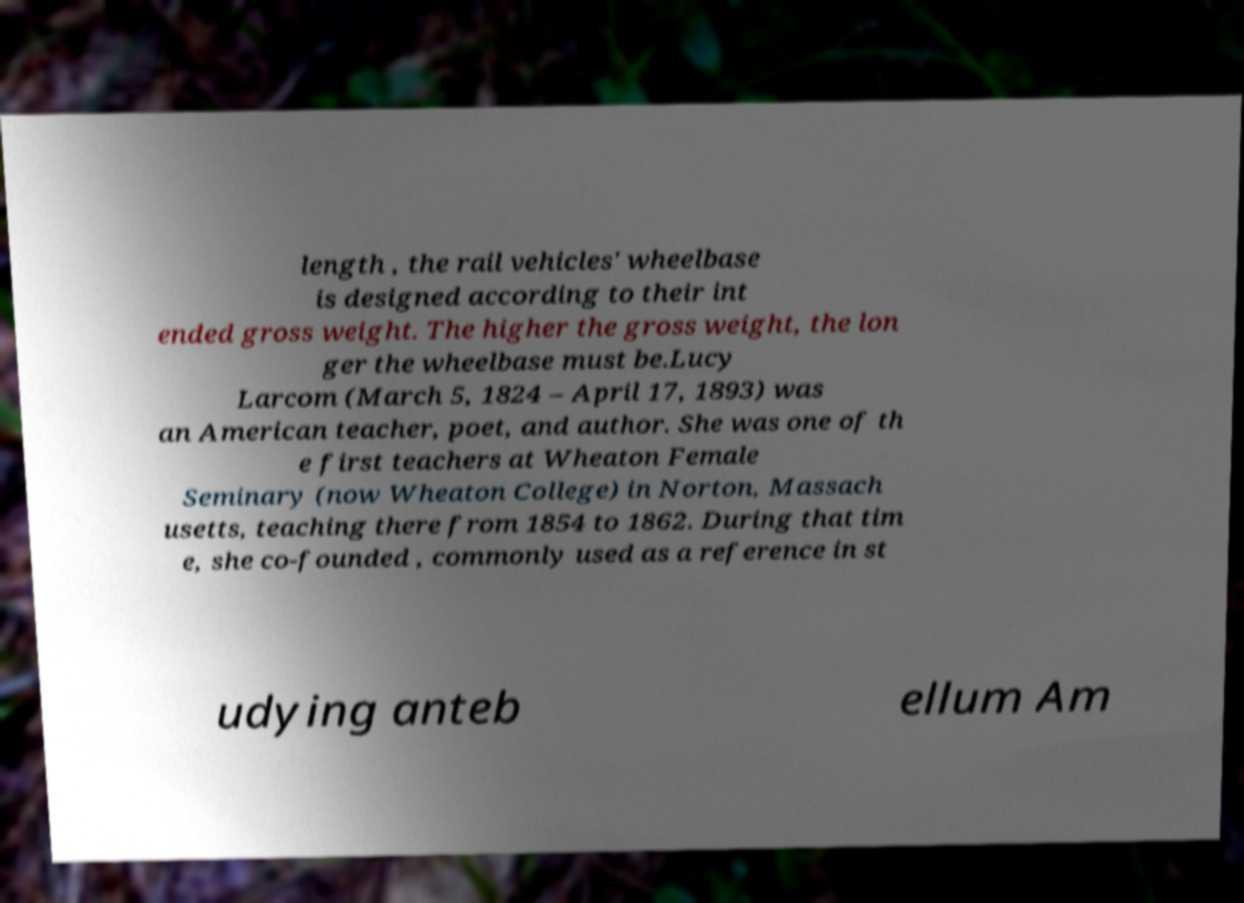I need the written content from this picture converted into text. Can you do that? length , the rail vehicles' wheelbase is designed according to their int ended gross weight. The higher the gross weight, the lon ger the wheelbase must be.Lucy Larcom (March 5, 1824 – April 17, 1893) was an American teacher, poet, and author. She was one of th e first teachers at Wheaton Female Seminary (now Wheaton College) in Norton, Massach usetts, teaching there from 1854 to 1862. During that tim e, she co-founded , commonly used as a reference in st udying anteb ellum Am 